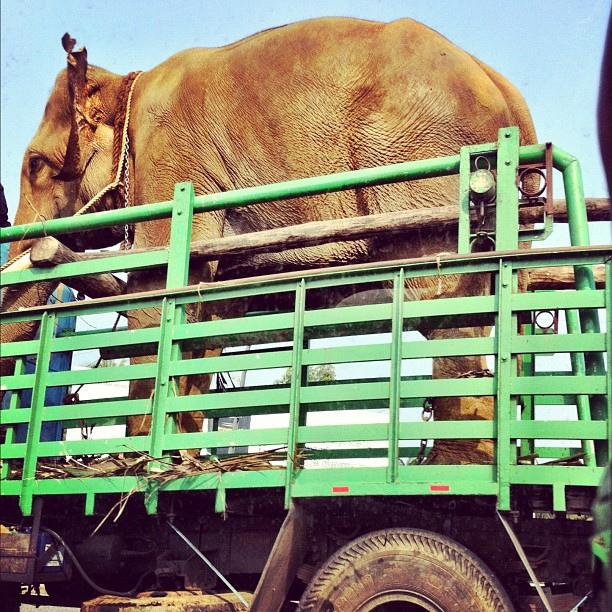Is the elephant at the zoo?
Quick response, please. No. How did they get the elephant on the truck?
Keep it brief. Ramp. What animal is in the back of the truck?
Answer briefly. Elephant. 